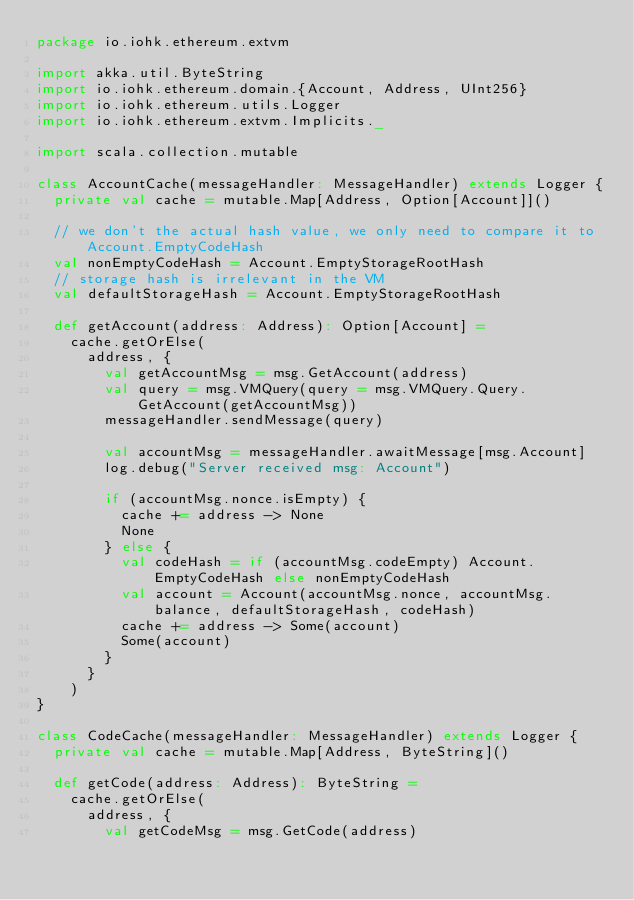Convert code to text. <code><loc_0><loc_0><loc_500><loc_500><_Scala_>package io.iohk.ethereum.extvm

import akka.util.ByteString
import io.iohk.ethereum.domain.{Account, Address, UInt256}
import io.iohk.ethereum.utils.Logger
import io.iohk.ethereum.extvm.Implicits._

import scala.collection.mutable

class AccountCache(messageHandler: MessageHandler) extends Logger {
  private val cache = mutable.Map[Address, Option[Account]]()

  // we don't the actual hash value, we only need to compare it to Account.EmptyCodeHash
  val nonEmptyCodeHash = Account.EmptyStorageRootHash
  // storage hash is irrelevant in the VM
  val defaultStorageHash = Account.EmptyStorageRootHash

  def getAccount(address: Address): Option[Account] =
    cache.getOrElse(
      address, {
        val getAccountMsg = msg.GetAccount(address)
        val query = msg.VMQuery(query = msg.VMQuery.Query.GetAccount(getAccountMsg))
        messageHandler.sendMessage(query)

        val accountMsg = messageHandler.awaitMessage[msg.Account]
        log.debug("Server received msg: Account")

        if (accountMsg.nonce.isEmpty) {
          cache += address -> None
          None
        } else {
          val codeHash = if (accountMsg.codeEmpty) Account.EmptyCodeHash else nonEmptyCodeHash
          val account = Account(accountMsg.nonce, accountMsg.balance, defaultStorageHash, codeHash)
          cache += address -> Some(account)
          Some(account)
        }
      }
    )
}

class CodeCache(messageHandler: MessageHandler) extends Logger {
  private val cache = mutable.Map[Address, ByteString]()

  def getCode(address: Address): ByteString =
    cache.getOrElse(
      address, {
        val getCodeMsg = msg.GetCode(address)</code> 